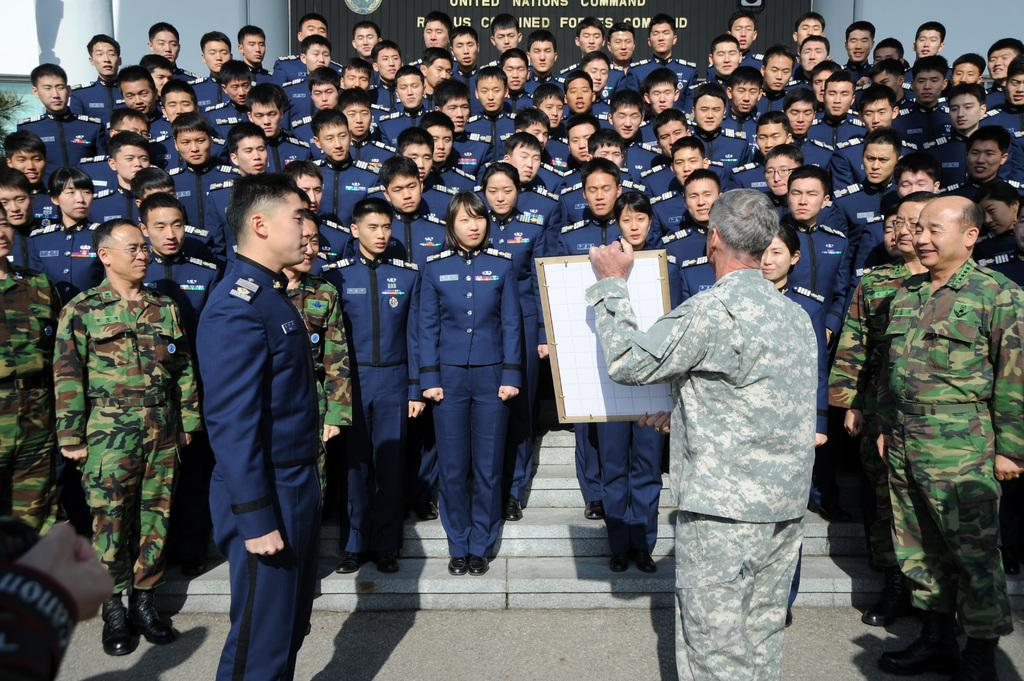What is happening in the image? There are people standing in the image, and a man is holding a board in the front. Can you describe the location or setting of the image? There are stairs in the middle of the image, which suggests it might be an outdoor or public area. What can be seen in the background of the image? There is text visible in the background, which could be a sign or advertisement. What type of waves can be seen crashing on the shore in the image? There are no waves or shore visible in the image; it features people standing near stairs with a man holding a board. 